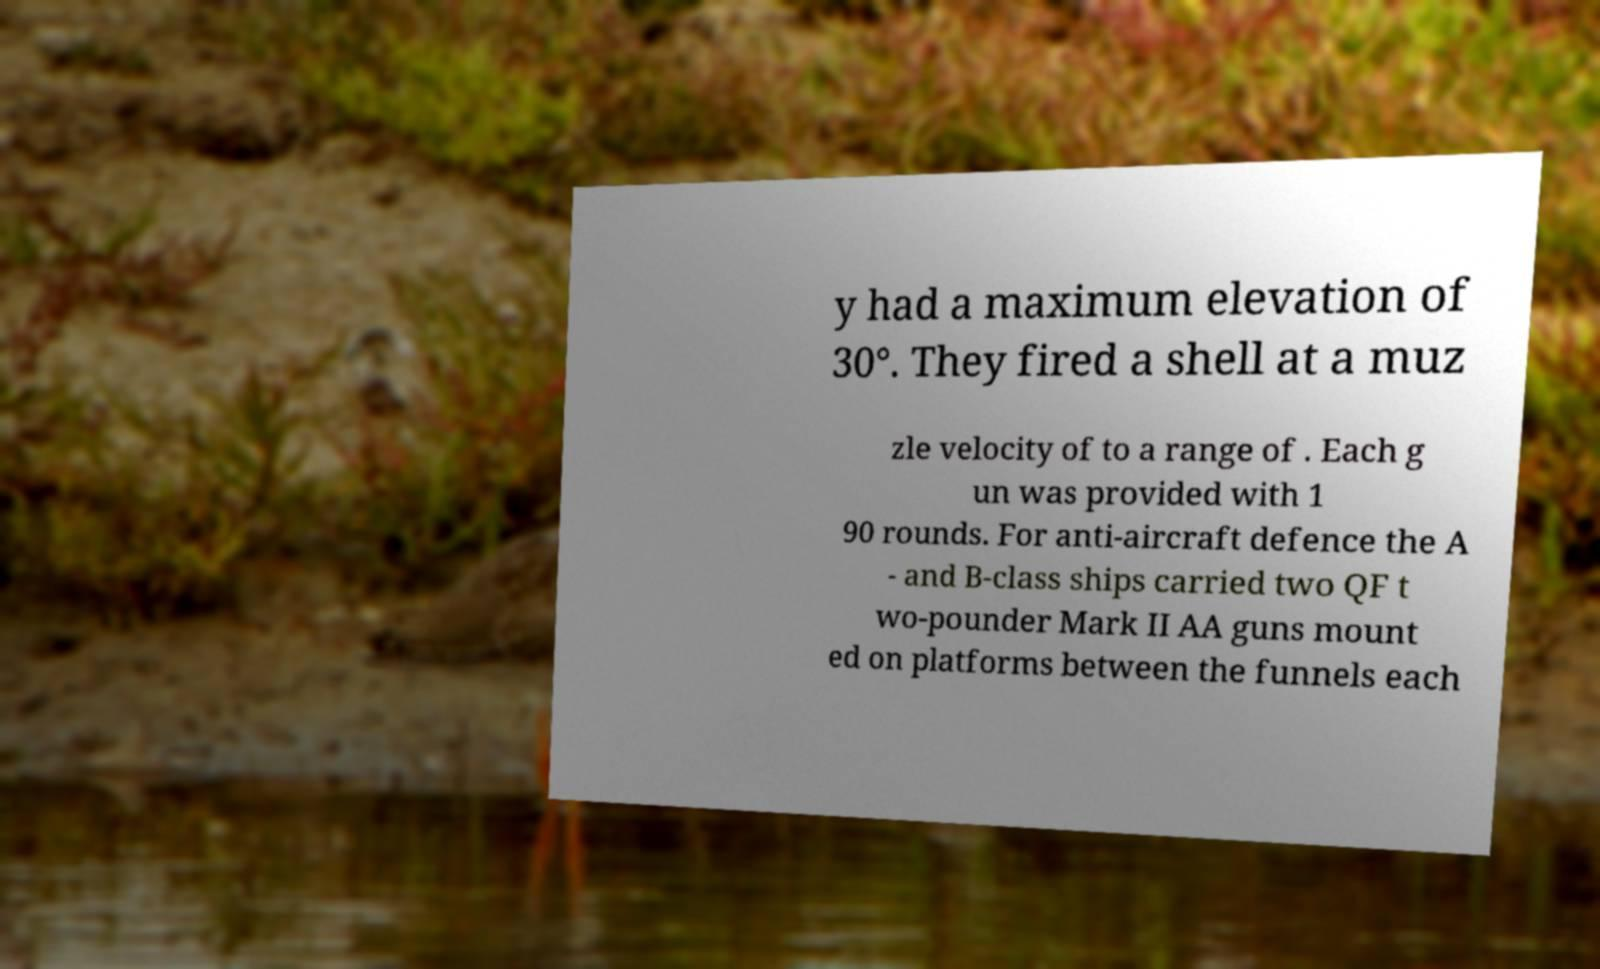I need the written content from this picture converted into text. Can you do that? y had a maximum elevation of 30°. They fired a shell at a muz zle velocity of to a range of . Each g un was provided with 1 90 rounds. For anti-aircraft defence the A - and B-class ships carried two QF t wo-pounder Mark II AA guns mount ed on platforms between the funnels each 